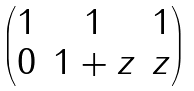<formula> <loc_0><loc_0><loc_500><loc_500>\begin{pmatrix} 1 & 1 & 1 \\ 0 & 1 + z & z \end{pmatrix}</formula> 